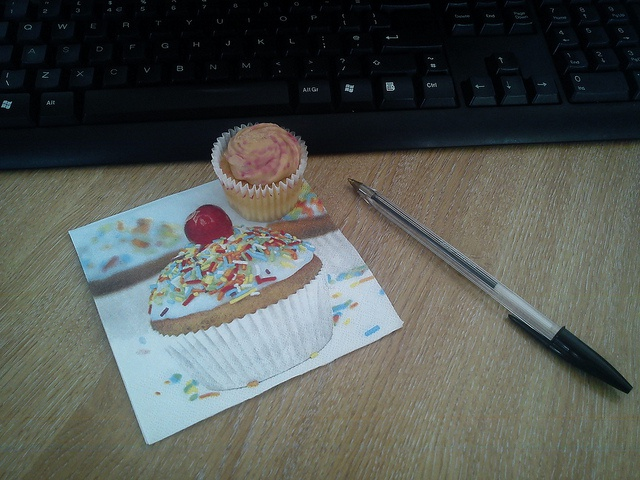Describe the objects in this image and their specific colors. I can see keyboard in black, purple, and darkblue tones, cake in black, lightblue, darkgray, and gray tones, and cake in black, gray, darkgray, and brown tones in this image. 